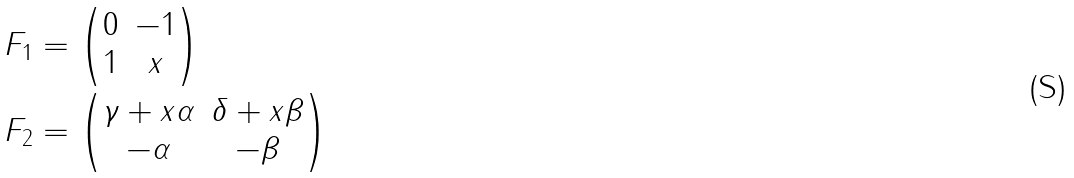Convert formula to latex. <formula><loc_0><loc_0><loc_500><loc_500>F _ { 1 } & = \begin{pmatrix} 0 & - 1 \\ 1 & x \end{pmatrix} \\ F _ { 2 } & = \begin{pmatrix} \gamma + x \alpha & \delta + x \beta \\ - \alpha & - \beta \end{pmatrix}</formula> 